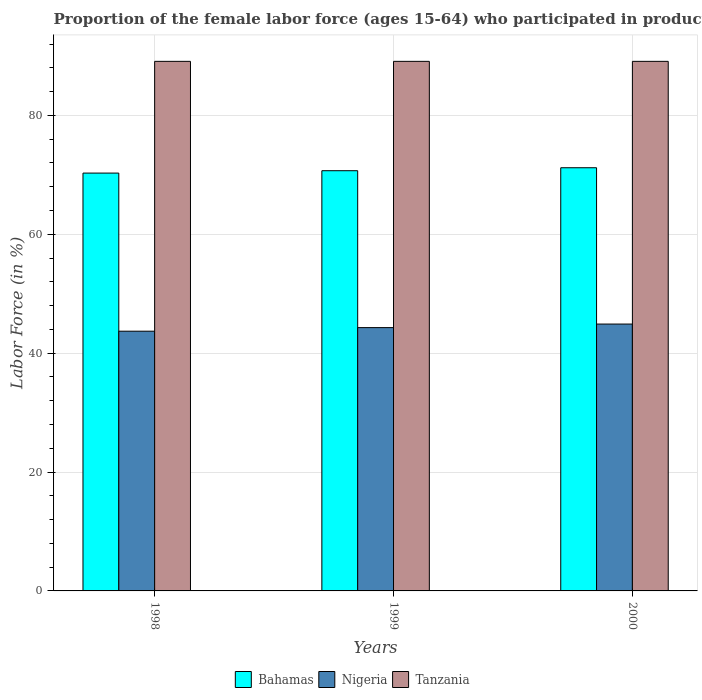How many groups of bars are there?
Give a very brief answer. 3. Are the number of bars on each tick of the X-axis equal?
Provide a succinct answer. Yes. What is the label of the 2nd group of bars from the left?
Provide a short and direct response. 1999. In how many cases, is the number of bars for a given year not equal to the number of legend labels?
Provide a short and direct response. 0. What is the proportion of the female labor force who participated in production in Nigeria in 2000?
Give a very brief answer. 44.9. Across all years, what is the maximum proportion of the female labor force who participated in production in Tanzania?
Provide a short and direct response. 89.1. Across all years, what is the minimum proportion of the female labor force who participated in production in Nigeria?
Provide a succinct answer. 43.7. In which year was the proportion of the female labor force who participated in production in Bahamas maximum?
Offer a very short reply. 2000. What is the total proportion of the female labor force who participated in production in Bahamas in the graph?
Provide a short and direct response. 212.2. What is the difference between the proportion of the female labor force who participated in production in Nigeria in 1998 and that in 1999?
Ensure brevity in your answer.  -0.6. What is the difference between the proportion of the female labor force who participated in production in Bahamas in 1998 and the proportion of the female labor force who participated in production in Nigeria in 1999?
Your response must be concise. 26. What is the average proportion of the female labor force who participated in production in Nigeria per year?
Make the answer very short. 44.3. In the year 2000, what is the difference between the proportion of the female labor force who participated in production in Nigeria and proportion of the female labor force who participated in production in Bahamas?
Your answer should be compact. -26.3. In how many years, is the proportion of the female labor force who participated in production in Tanzania greater than 56 %?
Keep it short and to the point. 3. What is the ratio of the proportion of the female labor force who participated in production in Bahamas in 1998 to that in 2000?
Your answer should be compact. 0.99. Is the proportion of the female labor force who participated in production in Bahamas in 1999 less than that in 2000?
Offer a terse response. Yes. What is the difference between the highest and the lowest proportion of the female labor force who participated in production in Bahamas?
Provide a short and direct response. 0.9. Is the sum of the proportion of the female labor force who participated in production in Nigeria in 1999 and 2000 greater than the maximum proportion of the female labor force who participated in production in Tanzania across all years?
Provide a short and direct response. Yes. What does the 1st bar from the left in 2000 represents?
Offer a terse response. Bahamas. What does the 1st bar from the right in 2000 represents?
Provide a short and direct response. Tanzania. Is it the case that in every year, the sum of the proportion of the female labor force who participated in production in Nigeria and proportion of the female labor force who participated in production in Tanzania is greater than the proportion of the female labor force who participated in production in Bahamas?
Keep it short and to the point. Yes. How many bars are there?
Keep it short and to the point. 9. What is the difference between two consecutive major ticks on the Y-axis?
Your answer should be very brief. 20. Are the values on the major ticks of Y-axis written in scientific E-notation?
Your answer should be compact. No. Where does the legend appear in the graph?
Make the answer very short. Bottom center. How are the legend labels stacked?
Offer a very short reply. Horizontal. What is the title of the graph?
Provide a short and direct response. Proportion of the female labor force (ages 15-64) who participated in production. Does "Micronesia" appear as one of the legend labels in the graph?
Make the answer very short. No. What is the label or title of the Y-axis?
Provide a succinct answer. Labor Force (in %). What is the Labor Force (in %) of Bahamas in 1998?
Offer a very short reply. 70.3. What is the Labor Force (in %) in Nigeria in 1998?
Offer a terse response. 43.7. What is the Labor Force (in %) of Tanzania in 1998?
Your answer should be very brief. 89.1. What is the Labor Force (in %) of Bahamas in 1999?
Make the answer very short. 70.7. What is the Labor Force (in %) of Nigeria in 1999?
Offer a very short reply. 44.3. What is the Labor Force (in %) in Tanzania in 1999?
Offer a very short reply. 89.1. What is the Labor Force (in %) of Bahamas in 2000?
Ensure brevity in your answer.  71.2. What is the Labor Force (in %) in Nigeria in 2000?
Give a very brief answer. 44.9. What is the Labor Force (in %) in Tanzania in 2000?
Provide a short and direct response. 89.1. Across all years, what is the maximum Labor Force (in %) of Bahamas?
Provide a short and direct response. 71.2. Across all years, what is the maximum Labor Force (in %) in Nigeria?
Provide a succinct answer. 44.9. Across all years, what is the maximum Labor Force (in %) of Tanzania?
Offer a terse response. 89.1. Across all years, what is the minimum Labor Force (in %) in Bahamas?
Make the answer very short. 70.3. Across all years, what is the minimum Labor Force (in %) of Nigeria?
Give a very brief answer. 43.7. Across all years, what is the minimum Labor Force (in %) of Tanzania?
Ensure brevity in your answer.  89.1. What is the total Labor Force (in %) of Bahamas in the graph?
Your response must be concise. 212.2. What is the total Labor Force (in %) in Nigeria in the graph?
Provide a short and direct response. 132.9. What is the total Labor Force (in %) of Tanzania in the graph?
Provide a succinct answer. 267.3. What is the difference between the Labor Force (in %) of Bahamas in 1998 and that in 1999?
Provide a succinct answer. -0.4. What is the difference between the Labor Force (in %) in Bahamas in 1998 and that in 2000?
Make the answer very short. -0.9. What is the difference between the Labor Force (in %) in Tanzania in 1998 and that in 2000?
Make the answer very short. 0. What is the difference between the Labor Force (in %) of Bahamas in 1998 and the Labor Force (in %) of Nigeria in 1999?
Provide a succinct answer. 26. What is the difference between the Labor Force (in %) in Bahamas in 1998 and the Labor Force (in %) in Tanzania in 1999?
Your response must be concise. -18.8. What is the difference between the Labor Force (in %) in Nigeria in 1998 and the Labor Force (in %) in Tanzania in 1999?
Provide a succinct answer. -45.4. What is the difference between the Labor Force (in %) in Bahamas in 1998 and the Labor Force (in %) in Nigeria in 2000?
Make the answer very short. 25.4. What is the difference between the Labor Force (in %) in Bahamas in 1998 and the Labor Force (in %) in Tanzania in 2000?
Offer a terse response. -18.8. What is the difference between the Labor Force (in %) of Nigeria in 1998 and the Labor Force (in %) of Tanzania in 2000?
Ensure brevity in your answer.  -45.4. What is the difference between the Labor Force (in %) of Bahamas in 1999 and the Labor Force (in %) of Nigeria in 2000?
Your answer should be very brief. 25.8. What is the difference between the Labor Force (in %) in Bahamas in 1999 and the Labor Force (in %) in Tanzania in 2000?
Give a very brief answer. -18.4. What is the difference between the Labor Force (in %) in Nigeria in 1999 and the Labor Force (in %) in Tanzania in 2000?
Your answer should be very brief. -44.8. What is the average Labor Force (in %) of Bahamas per year?
Offer a very short reply. 70.73. What is the average Labor Force (in %) of Nigeria per year?
Provide a short and direct response. 44.3. What is the average Labor Force (in %) of Tanzania per year?
Ensure brevity in your answer.  89.1. In the year 1998, what is the difference between the Labor Force (in %) in Bahamas and Labor Force (in %) in Nigeria?
Provide a succinct answer. 26.6. In the year 1998, what is the difference between the Labor Force (in %) in Bahamas and Labor Force (in %) in Tanzania?
Keep it short and to the point. -18.8. In the year 1998, what is the difference between the Labor Force (in %) in Nigeria and Labor Force (in %) in Tanzania?
Provide a succinct answer. -45.4. In the year 1999, what is the difference between the Labor Force (in %) in Bahamas and Labor Force (in %) in Nigeria?
Your answer should be very brief. 26.4. In the year 1999, what is the difference between the Labor Force (in %) of Bahamas and Labor Force (in %) of Tanzania?
Give a very brief answer. -18.4. In the year 1999, what is the difference between the Labor Force (in %) of Nigeria and Labor Force (in %) of Tanzania?
Make the answer very short. -44.8. In the year 2000, what is the difference between the Labor Force (in %) of Bahamas and Labor Force (in %) of Nigeria?
Ensure brevity in your answer.  26.3. In the year 2000, what is the difference between the Labor Force (in %) of Bahamas and Labor Force (in %) of Tanzania?
Provide a short and direct response. -17.9. In the year 2000, what is the difference between the Labor Force (in %) of Nigeria and Labor Force (in %) of Tanzania?
Your answer should be compact. -44.2. What is the ratio of the Labor Force (in %) of Bahamas in 1998 to that in 1999?
Your answer should be compact. 0.99. What is the ratio of the Labor Force (in %) in Nigeria in 1998 to that in 1999?
Your answer should be very brief. 0.99. What is the ratio of the Labor Force (in %) of Tanzania in 1998 to that in 1999?
Provide a succinct answer. 1. What is the ratio of the Labor Force (in %) in Bahamas in 1998 to that in 2000?
Make the answer very short. 0.99. What is the ratio of the Labor Force (in %) in Nigeria in 1998 to that in 2000?
Your answer should be very brief. 0.97. What is the ratio of the Labor Force (in %) of Bahamas in 1999 to that in 2000?
Offer a very short reply. 0.99. What is the ratio of the Labor Force (in %) of Nigeria in 1999 to that in 2000?
Your answer should be very brief. 0.99. What is the ratio of the Labor Force (in %) in Tanzania in 1999 to that in 2000?
Keep it short and to the point. 1. What is the difference between the highest and the second highest Labor Force (in %) in Nigeria?
Give a very brief answer. 0.6. 